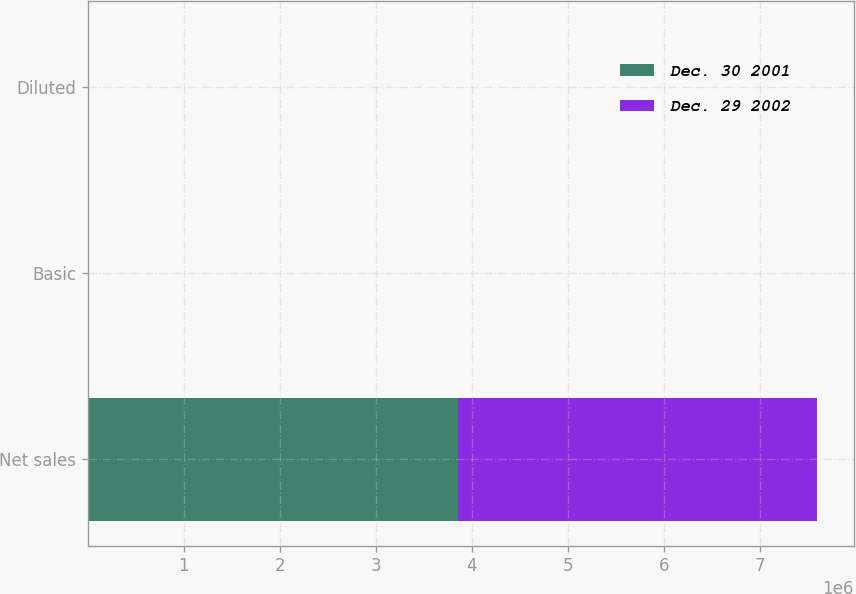Convert chart. <chart><loc_0><loc_0><loc_500><loc_500><stacked_bar_chart><ecel><fcel>Net sales<fcel>Basic<fcel>Diluted<nl><fcel>Dec. 30 2001<fcel>3.85759e+06<fcel>4.11<fcel>4.06<nl><fcel>Dec. 29 2002<fcel>3.74008e+06<fcel>3.78<fcel>3.75<nl></chart> 